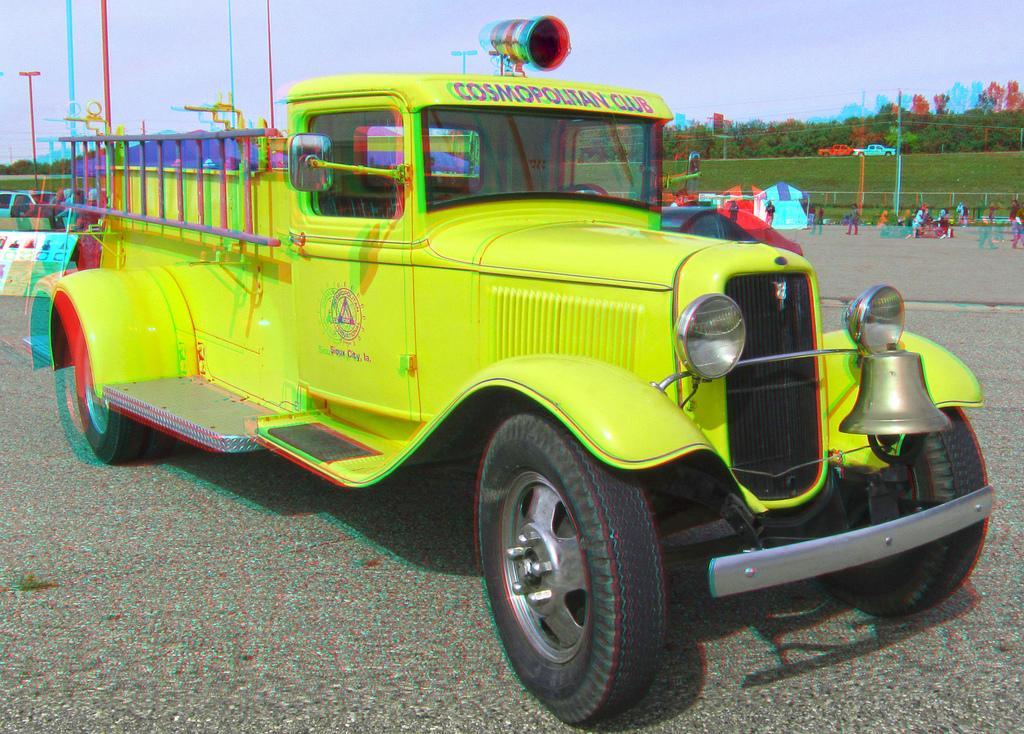Please provide a concise description of this image. Here we can see a green color vehicle with wheels on the surface. Background there are vehicles, tents, poles, trees, people and grass. 